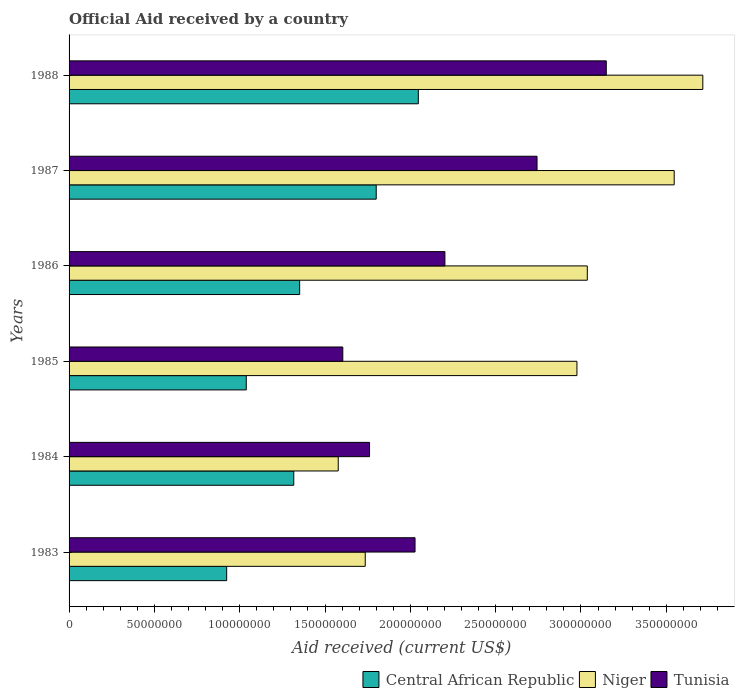How many different coloured bars are there?
Offer a very short reply. 3. Are the number of bars per tick equal to the number of legend labels?
Keep it short and to the point. Yes. Are the number of bars on each tick of the Y-axis equal?
Make the answer very short. Yes. How many bars are there on the 2nd tick from the top?
Provide a succinct answer. 3. How many bars are there on the 6th tick from the bottom?
Offer a terse response. 3. What is the label of the 1st group of bars from the top?
Ensure brevity in your answer.  1988. In how many cases, is the number of bars for a given year not equal to the number of legend labels?
Offer a very short reply. 0. What is the net official aid received in Tunisia in 1987?
Give a very brief answer. 2.74e+08. Across all years, what is the maximum net official aid received in Niger?
Ensure brevity in your answer.  3.71e+08. Across all years, what is the minimum net official aid received in Niger?
Provide a short and direct response. 1.58e+08. What is the total net official aid received in Central African Republic in the graph?
Provide a short and direct response. 8.48e+08. What is the difference between the net official aid received in Niger in 1987 and that in 1988?
Your answer should be compact. -1.68e+07. What is the difference between the net official aid received in Tunisia in 1986 and the net official aid received in Niger in 1984?
Keep it short and to the point. 6.25e+07. What is the average net official aid received in Tunisia per year?
Give a very brief answer. 2.25e+08. In the year 1985, what is the difference between the net official aid received in Tunisia and net official aid received in Central African Republic?
Offer a very short reply. 5.66e+07. In how many years, is the net official aid received in Tunisia greater than 310000000 US$?
Your answer should be compact. 1. What is the ratio of the net official aid received in Tunisia in 1983 to that in 1986?
Make the answer very short. 0.92. What is the difference between the highest and the second highest net official aid received in Niger?
Ensure brevity in your answer.  1.68e+07. What is the difference between the highest and the lowest net official aid received in Niger?
Your answer should be very brief. 2.14e+08. Is the sum of the net official aid received in Niger in 1984 and 1988 greater than the maximum net official aid received in Central African Republic across all years?
Offer a terse response. Yes. What does the 2nd bar from the top in 1986 represents?
Ensure brevity in your answer.  Niger. What does the 2nd bar from the bottom in 1985 represents?
Provide a succinct answer. Niger. Is it the case that in every year, the sum of the net official aid received in Niger and net official aid received in Tunisia is greater than the net official aid received in Central African Republic?
Provide a short and direct response. Yes. Are all the bars in the graph horizontal?
Your answer should be compact. Yes. What is the difference between two consecutive major ticks on the X-axis?
Offer a very short reply. 5.00e+07. Does the graph contain any zero values?
Provide a short and direct response. No. Does the graph contain grids?
Offer a very short reply. No. Where does the legend appear in the graph?
Provide a succinct answer. Bottom right. How many legend labels are there?
Keep it short and to the point. 3. What is the title of the graph?
Your answer should be very brief. Official Aid received by a country. Does "Rwanda" appear as one of the legend labels in the graph?
Your response must be concise. No. What is the label or title of the X-axis?
Keep it short and to the point. Aid received (current US$). What is the label or title of the Y-axis?
Make the answer very short. Years. What is the Aid received (current US$) of Central African Republic in 1983?
Provide a succinct answer. 9.24e+07. What is the Aid received (current US$) in Niger in 1983?
Your answer should be very brief. 1.74e+08. What is the Aid received (current US$) in Tunisia in 1983?
Offer a terse response. 2.03e+08. What is the Aid received (current US$) of Central African Republic in 1984?
Offer a terse response. 1.32e+08. What is the Aid received (current US$) of Niger in 1984?
Provide a succinct answer. 1.58e+08. What is the Aid received (current US$) in Tunisia in 1984?
Make the answer very short. 1.76e+08. What is the Aid received (current US$) in Central African Republic in 1985?
Your response must be concise. 1.04e+08. What is the Aid received (current US$) of Niger in 1985?
Keep it short and to the point. 2.98e+08. What is the Aid received (current US$) in Tunisia in 1985?
Offer a very short reply. 1.60e+08. What is the Aid received (current US$) in Central African Republic in 1986?
Your response must be concise. 1.35e+08. What is the Aid received (current US$) of Niger in 1986?
Make the answer very short. 3.04e+08. What is the Aid received (current US$) of Tunisia in 1986?
Your answer should be very brief. 2.20e+08. What is the Aid received (current US$) of Central African Republic in 1987?
Provide a short and direct response. 1.80e+08. What is the Aid received (current US$) of Niger in 1987?
Offer a very short reply. 3.55e+08. What is the Aid received (current US$) of Tunisia in 1987?
Offer a terse response. 2.74e+08. What is the Aid received (current US$) in Central African Republic in 1988?
Keep it short and to the point. 2.05e+08. What is the Aid received (current US$) in Niger in 1988?
Provide a short and direct response. 3.71e+08. What is the Aid received (current US$) of Tunisia in 1988?
Offer a terse response. 3.15e+08. Across all years, what is the maximum Aid received (current US$) of Central African Republic?
Offer a very short reply. 2.05e+08. Across all years, what is the maximum Aid received (current US$) in Niger?
Your answer should be compact. 3.71e+08. Across all years, what is the maximum Aid received (current US$) of Tunisia?
Offer a very short reply. 3.15e+08. Across all years, what is the minimum Aid received (current US$) in Central African Republic?
Ensure brevity in your answer.  9.24e+07. Across all years, what is the minimum Aid received (current US$) of Niger?
Your answer should be compact. 1.58e+08. Across all years, what is the minimum Aid received (current US$) of Tunisia?
Provide a succinct answer. 1.60e+08. What is the total Aid received (current US$) in Central African Republic in the graph?
Your answer should be very brief. 8.48e+08. What is the total Aid received (current US$) in Niger in the graph?
Your answer should be compact. 1.66e+09. What is the total Aid received (current US$) of Tunisia in the graph?
Provide a succinct answer. 1.35e+09. What is the difference between the Aid received (current US$) in Central African Republic in 1983 and that in 1984?
Your answer should be compact. -3.93e+07. What is the difference between the Aid received (current US$) of Niger in 1983 and that in 1984?
Keep it short and to the point. 1.58e+07. What is the difference between the Aid received (current US$) of Tunisia in 1983 and that in 1984?
Your answer should be very brief. 2.67e+07. What is the difference between the Aid received (current US$) of Central African Republic in 1983 and that in 1985?
Provide a succinct answer. -1.15e+07. What is the difference between the Aid received (current US$) of Niger in 1983 and that in 1985?
Your answer should be very brief. -1.24e+08. What is the difference between the Aid received (current US$) of Tunisia in 1983 and that in 1985?
Offer a terse response. 4.23e+07. What is the difference between the Aid received (current US$) of Central African Republic in 1983 and that in 1986?
Provide a short and direct response. -4.28e+07. What is the difference between the Aid received (current US$) of Niger in 1983 and that in 1986?
Offer a terse response. -1.30e+08. What is the difference between the Aid received (current US$) in Tunisia in 1983 and that in 1986?
Offer a terse response. -1.75e+07. What is the difference between the Aid received (current US$) in Central African Republic in 1983 and that in 1987?
Offer a very short reply. -8.76e+07. What is the difference between the Aid received (current US$) in Niger in 1983 and that in 1987?
Your response must be concise. -1.81e+08. What is the difference between the Aid received (current US$) in Tunisia in 1983 and that in 1987?
Make the answer very short. -7.15e+07. What is the difference between the Aid received (current US$) in Central African Republic in 1983 and that in 1988?
Ensure brevity in your answer.  -1.12e+08. What is the difference between the Aid received (current US$) in Niger in 1983 and that in 1988?
Offer a very short reply. -1.98e+08. What is the difference between the Aid received (current US$) in Tunisia in 1983 and that in 1988?
Your response must be concise. -1.12e+08. What is the difference between the Aid received (current US$) of Central African Republic in 1984 and that in 1985?
Ensure brevity in your answer.  2.78e+07. What is the difference between the Aid received (current US$) of Niger in 1984 and that in 1985?
Provide a succinct answer. -1.40e+08. What is the difference between the Aid received (current US$) of Tunisia in 1984 and that in 1985?
Your response must be concise. 1.57e+07. What is the difference between the Aid received (current US$) of Central African Republic in 1984 and that in 1986?
Offer a very short reply. -3.45e+06. What is the difference between the Aid received (current US$) in Niger in 1984 and that in 1986?
Your response must be concise. -1.46e+08. What is the difference between the Aid received (current US$) of Tunisia in 1984 and that in 1986?
Provide a short and direct response. -4.42e+07. What is the difference between the Aid received (current US$) in Central African Republic in 1984 and that in 1987?
Ensure brevity in your answer.  -4.83e+07. What is the difference between the Aid received (current US$) of Niger in 1984 and that in 1987?
Make the answer very short. -1.97e+08. What is the difference between the Aid received (current US$) in Tunisia in 1984 and that in 1987?
Your answer should be compact. -9.82e+07. What is the difference between the Aid received (current US$) in Central African Republic in 1984 and that in 1988?
Keep it short and to the point. -7.30e+07. What is the difference between the Aid received (current US$) in Niger in 1984 and that in 1988?
Give a very brief answer. -2.14e+08. What is the difference between the Aid received (current US$) of Tunisia in 1984 and that in 1988?
Ensure brevity in your answer.  -1.39e+08. What is the difference between the Aid received (current US$) in Central African Republic in 1985 and that in 1986?
Give a very brief answer. -3.13e+07. What is the difference between the Aid received (current US$) of Niger in 1985 and that in 1986?
Your answer should be very brief. -6.07e+06. What is the difference between the Aid received (current US$) of Tunisia in 1985 and that in 1986?
Your answer should be compact. -5.98e+07. What is the difference between the Aid received (current US$) of Central African Republic in 1985 and that in 1987?
Provide a succinct answer. -7.62e+07. What is the difference between the Aid received (current US$) in Niger in 1985 and that in 1987?
Your response must be concise. -5.70e+07. What is the difference between the Aid received (current US$) of Tunisia in 1985 and that in 1987?
Your answer should be very brief. -1.14e+08. What is the difference between the Aid received (current US$) in Central African Republic in 1985 and that in 1988?
Keep it short and to the point. -1.01e+08. What is the difference between the Aid received (current US$) of Niger in 1985 and that in 1988?
Your response must be concise. -7.38e+07. What is the difference between the Aid received (current US$) of Tunisia in 1985 and that in 1988?
Your response must be concise. -1.54e+08. What is the difference between the Aid received (current US$) of Central African Republic in 1986 and that in 1987?
Ensure brevity in your answer.  -4.49e+07. What is the difference between the Aid received (current US$) in Niger in 1986 and that in 1987?
Offer a terse response. -5.09e+07. What is the difference between the Aid received (current US$) in Tunisia in 1986 and that in 1987?
Make the answer very short. -5.40e+07. What is the difference between the Aid received (current US$) of Central African Republic in 1986 and that in 1988?
Offer a very short reply. -6.96e+07. What is the difference between the Aid received (current US$) of Niger in 1986 and that in 1988?
Offer a very short reply. -6.77e+07. What is the difference between the Aid received (current US$) of Tunisia in 1986 and that in 1988?
Make the answer very short. -9.46e+07. What is the difference between the Aid received (current US$) in Central African Republic in 1987 and that in 1988?
Offer a very short reply. -2.47e+07. What is the difference between the Aid received (current US$) of Niger in 1987 and that in 1988?
Keep it short and to the point. -1.68e+07. What is the difference between the Aid received (current US$) of Tunisia in 1987 and that in 1988?
Provide a succinct answer. -4.06e+07. What is the difference between the Aid received (current US$) in Central African Republic in 1983 and the Aid received (current US$) in Niger in 1984?
Give a very brief answer. -6.54e+07. What is the difference between the Aid received (current US$) of Central African Republic in 1983 and the Aid received (current US$) of Tunisia in 1984?
Make the answer very short. -8.37e+07. What is the difference between the Aid received (current US$) of Niger in 1983 and the Aid received (current US$) of Tunisia in 1984?
Ensure brevity in your answer.  -2.53e+06. What is the difference between the Aid received (current US$) in Central African Republic in 1983 and the Aid received (current US$) in Niger in 1985?
Provide a short and direct response. -2.05e+08. What is the difference between the Aid received (current US$) of Central African Republic in 1983 and the Aid received (current US$) of Tunisia in 1985?
Ensure brevity in your answer.  -6.81e+07. What is the difference between the Aid received (current US$) of Niger in 1983 and the Aid received (current US$) of Tunisia in 1985?
Your answer should be compact. 1.32e+07. What is the difference between the Aid received (current US$) of Central African Republic in 1983 and the Aid received (current US$) of Niger in 1986?
Provide a succinct answer. -2.11e+08. What is the difference between the Aid received (current US$) of Central African Republic in 1983 and the Aid received (current US$) of Tunisia in 1986?
Provide a short and direct response. -1.28e+08. What is the difference between the Aid received (current US$) of Niger in 1983 and the Aid received (current US$) of Tunisia in 1986?
Offer a very short reply. -4.67e+07. What is the difference between the Aid received (current US$) in Central African Republic in 1983 and the Aid received (current US$) in Niger in 1987?
Your answer should be compact. -2.62e+08. What is the difference between the Aid received (current US$) in Central African Republic in 1983 and the Aid received (current US$) in Tunisia in 1987?
Your answer should be compact. -1.82e+08. What is the difference between the Aid received (current US$) of Niger in 1983 and the Aid received (current US$) of Tunisia in 1987?
Provide a succinct answer. -1.01e+08. What is the difference between the Aid received (current US$) in Central African Republic in 1983 and the Aid received (current US$) in Niger in 1988?
Ensure brevity in your answer.  -2.79e+08. What is the difference between the Aid received (current US$) in Central African Republic in 1983 and the Aid received (current US$) in Tunisia in 1988?
Provide a succinct answer. -2.22e+08. What is the difference between the Aid received (current US$) in Niger in 1983 and the Aid received (current US$) in Tunisia in 1988?
Your answer should be very brief. -1.41e+08. What is the difference between the Aid received (current US$) of Central African Republic in 1984 and the Aid received (current US$) of Niger in 1985?
Your answer should be very brief. -1.66e+08. What is the difference between the Aid received (current US$) in Central African Republic in 1984 and the Aid received (current US$) in Tunisia in 1985?
Your answer should be compact. -2.87e+07. What is the difference between the Aid received (current US$) of Niger in 1984 and the Aid received (current US$) of Tunisia in 1985?
Make the answer very short. -2.67e+06. What is the difference between the Aid received (current US$) in Central African Republic in 1984 and the Aid received (current US$) in Niger in 1986?
Offer a very short reply. -1.72e+08. What is the difference between the Aid received (current US$) in Central African Republic in 1984 and the Aid received (current US$) in Tunisia in 1986?
Provide a short and direct response. -8.86e+07. What is the difference between the Aid received (current US$) in Niger in 1984 and the Aid received (current US$) in Tunisia in 1986?
Your response must be concise. -6.25e+07. What is the difference between the Aid received (current US$) in Central African Republic in 1984 and the Aid received (current US$) in Niger in 1987?
Your answer should be compact. -2.23e+08. What is the difference between the Aid received (current US$) in Central African Republic in 1984 and the Aid received (current US$) in Tunisia in 1987?
Make the answer very short. -1.43e+08. What is the difference between the Aid received (current US$) of Niger in 1984 and the Aid received (current US$) of Tunisia in 1987?
Your response must be concise. -1.17e+08. What is the difference between the Aid received (current US$) of Central African Republic in 1984 and the Aid received (current US$) of Niger in 1988?
Your response must be concise. -2.40e+08. What is the difference between the Aid received (current US$) of Central African Republic in 1984 and the Aid received (current US$) of Tunisia in 1988?
Provide a short and direct response. -1.83e+08. What is the difference between the Aid received (current US$) of Niger in 1984 and the Aid received (current US$) of Tunisia in 1988?
Give a very brief answer. -1.57e+08. What is the difference between the Aid received (current US$) in Central African Republic in 1985 and the Aid received (current US$) in Niger in 1986?
Offer a very short reply. -2.00e+08. What is the difference between the Aid received (current US$) in Central African Republic in 1985 and the Aid received (current US$) in Tunisia in 1986?
Provide a succinct answer. -1.16e+08. What is the difference between the Aid received (current US$) in Niger in 1985 and the Aid received (current US$) in Tunisia in 1986?
Provide a succinct answer. 7.74e+07. What is the difference between the Aid received (current US$) of Central African Republic in 1985 and the Aid received (current US$) of Niger in 1987?
Provide a short and direct response. -2.51e+08. What is the difference between the Aid received (current US$) of Central African Republic in 1985 and the Aid received (current US$) of Tunisia in 1987?
Ensure brevity in your answer.  -1.70e+08. What is the difference between the Aid received (current US$) of Niger in 1985 and the Aid received (current US$) of Tunisia in 1987?
Provide a short and direct response. 2.34e+07. What is the difference between the Aid received (current US$) of Central African Republic in 1985 and the Aid received (current US$) of Niger in 1988?
Make the answer very short. -2.68e+08. What is the difference between the Aid received (current US$) of Central African Republic in 1985 and the Aid received (current US$) of Tunisia in 1988?
Give a very brief answer. -2.11e+08. What is the difference between the Aid received (current US$) of Niger in 1985 and the Aid received (current US$) of Tunisia in 1988?
Ensure brevity in your answer.  -1.72e+07. What is the difference between the Aid received (current US$) of Central African Republic in 1986 and the Aid received (current US$) of Niger in 1987?
Your response must be concise. -2.20e+08. What is the difference between the Aid received (current US$) in Central African Republic in 1986 and the Aid received (current US$) in Tunisia in 1987?
Provide a succinct answer. -1.39e+08. What is the difference between the Aid received (current US$) in Niger in 1986 and the Aid received (current US$) in Tunisia in 1987?
Make the answer very short. 2.94e+07. What is the difference between the Aid received (current US$) in Central African Republic in 1986 and the Aid received (current US$) in Niger in 1988?
Your answer should be compact. -2.36e+08. What is the difference between the Aid received (current US$) in Central African Republic in 1986 and the Aid received (current US$) in Tunisia in 1988?
Offer a very short reply. -1.80e+08. What is the difference between the Aid received (current US$) in Niger in 1986 and the Aid received (current US$) in Tunisia in 1988?
Give a very brief answer. -1.11e+07. What is the difference between the Aid received (current US$) in Central African Republic in 1987 and the Aid received (current US$) in Niger in 1988?
Provide a short and direct response. -1.91e+08. What is the difference between the Aid received (current US$) of Central African Republic in 1987 and the Aid received (current US$) of Tunisia in 1988?
Provide a short and direct response. -1.35e+08. What is the difference between the Aid received (current US$) in Niger in 1987 and the Aid received (current US$) in Tunisia in 1988?
Keep it short and to the point. 3.98e+07. What is the average Aid received (current US$) in Central African Republic per year?
Your answer should be very brief. 1.41e+08. What is the average Aid received (current US$) in Niger per year?
Make the answer very short. 2.76e+08. What is the average Aid received (current US$) in Tunisia per year?
Ensure brevity in your answer.  2.25e+08. In the year 1983, what is the difference between the Aid received (current US$) of Central African Republic and Aid received (current US$) of Niger?
Give a very brief answer. -8.12e+07. In the year 1983, what is the difference between the Aid received (current US$) in Central African Republic and Aid received (current US$) in Tunisia?
Give a very brief answer. -1.10e+08. In the year 1983, what is the difference between the Aid received (current US$) of Niger and Aid received (current US$) of Tunisia?
Offer a terse response. -2.92e+07. In the year 1984, what is the difference between the Aid received (current US$) in Central African Republic and Aid received (current US$) in Niger?
Provide a succinct answer. -2.61e+07. In the year 1984, what is the difference between the Aid received (current US$) of Central African Republic and Aid received (current US$) of Tunisia?
Provide a short and direct response. -4.44e+07. In the year 1984, what is the difference between the Aid received (current US$) in Niger and Aid received (current US$) in Tunisia?
Your response must be concise. -1.84e+07. In the year 1985, what is the difference between the Aid received (current US$) in Central African Republic and Aid received (current US$) in Niger?
Provide a short and direct response. -1.94e+08. In the year 1985, what is the difference between the Aid received (current US$) in Central African Republic and Aid received (current US$) in Tunisia?
Offer a very short reply. -5.66e+07. In the year 1985, what is the difference between the Aid received (current US$) in Niger and Aid received (current US$) in Tunisia?
Your response must be concise. 1.37e+08. In the year 1986, what is the difference between the Aid received (current US$) in Central African Republic and Aid received (current US$) in Niger?
Your answer should be compact. -1.69e+08. In the year 1986, what is the difference between the Aid received (current US$) in Central African Republic and Aid received (current US$) in Tunisia?
Make the answer very short. -8.51e+07. In the year 1986, what is the difference between the Aid received (current US$) in Niger and Aid received (current US$) in Tunisia?
Your response must be concise. 8.34e+07. In the year 1987, what is the difference between the Aid received (current US$) of Central African Republic and Aid received (current US$) of Niger?
Offer a terse response. -1.75e+08. In the year 1987, what is the difference between the Aid received (current US$) of Central African Republic and Aid received (current US$) of Tunisia?
Offer a very short reply. -9.42e+07. In the year 1987, what is the difference between the Aid received (current US$) in Niger and Aid received (current US$) in Tunisia?
Offer a terse response. 8.04e+07. In the year 1988, what is the difference between the Aid received (current US$) of Central African Republic and Aid received (current US$) of Niger?
Offer a very short reply. -1.67e+08. In the year 1988, what is the difference between the Aid received (current US$) of Central African Republic and Aid received (current US$) of Tunisia?
Offer a very short reply. -1.10e+08. In the year 1988, what is the difference between the Aid received (current US$) in Niger and Aid received (current US$) in Tunisia?
Offer a very short reply. 5.66e+07. What is the ratio of the Aid received (current US$) in Central African Republic in 1983 to that in 1984?
Give a very brief answer. 0.7. What is the ratio of the Aid received (current US$) of Niger in 1983 to that in 1984?
Offer a terse response. 1.1. What is the ratio of the Aid received (current US$) in Tunisia in 1983 to that in 1984?
Keep it short and to the point. 1.15. What is the ratio of the Aid received (current US$) in Central African Republic in 1983 to that in 1985?
Offer a terse response. 0.89. What is the ratio of the Aid received (current US$) in Niger in 1983 to that in 1985?
Give a very brief answer. 0.58. What is the ratio of the Aid received (current US$) in Tunisia in 1983 to that in 1985?
Make the answer very short. 1.26. What is the ratio of the Aid received (current US$) of Central African Republic in 1983 to that in 1986?
Ensure brevity in your answer.  0.68. What is the ratio of the Aid received (current US$) in Niger in 1983 to that in 1986?
Ensure brevity in your answer.  0.57. What is the ratio of the Aid received (current US$) in Tunisia in 1983 to that in 1986?
Your response must be concise. 0.92. What is the ratio of the Aid received (current US$) in Central African Republic in 1983 to that in 1987?
Provide a succinct answer. 0.51. What is the ratio of the Aid received (current US$) of Niger in 1983 to that in 1987?
Make the answer very short. 0.49. What is the ratio of the Aid received (current US$) of Tunisia in 1983 to that in 1987?
Your response must be concise. 0.74. What is the ratio of the Aid received (current US$) of Central African Republic in 1983 to that in 1988?
Ensure brevity in your answer.  0.45. What is the ratio of the Aid received (current US$) of Niger in 1983 to that in 1988?
Offer a very short reply. 0.47. What is the ratio of the Aid received (current US$) of Tunisia in 1983 to that in 1988?
Provide a succinct answer. 0.64. What is the ratio of the Aid received (current US$) in Central African Republic in 1984 to that in 1985?
Your answer should be very brief. 1.27. What is the ratio of the Aid received (current US$) in Niger in 1984 to that in 1985?
Make the answer very short. 0.53. What is the ratio of the Aid received (current US$) in Tunisia in 1984 to that in 1985?
Offer a terse response. 1.1. What is the ratio of the Aid received (current US$) in Central African Republic in 1984 to that in 1986?
Your answer should be compact. 0.97. What is the ratio of the Aid received (current US$) in Niger in 1984 to that in 1986?
Ensure brevity in your answer.  0.52. What is the ratio of the Aid received (current US$) in Tunisia in 1984 to that in 1986?
Provide a succinct answer. 0.8. What is the ratio of the Aid received (current US$) of Central African Republic in 1984 to that in 1987?
Make the answer very short. 0.73. What is the ratio of the Aid received (current US$) in Niger in 1984 to that in 1987?
Provide a short and direct response. 0.44. What is the ratio of the Aid received (current US$) of Tunisia in 1984 to that in 1987?
Offer a very short reply. 0.64. What is the ratio of the Aid received (current US$) in Central African Republic in 1984 to that in 1988?
Your answer should be very brief. 0.64. What is the ratio of the Aid received (current US$) in Niger in 1984 to that in 1988?
Keep it short and to the point. 0.42. What is the ratio of the Aid received (current US$) in Tunisia in 1984 to that in 1988?
Give a very brief answer. 0.56. What is the ratio of the Aid received (current US$) in Central African Republic in 1985 to that in 1986?
Your answer should be very brief. 0.77. What is the ratio of the Aid received (current US$) in Niger in 1985 to that in 1986?
Ensure brevity in your answer.  0.98. What is the ratio of the Aid received (current US$) of Tunisia in 1985 to that in 1986?
Provide a short and direct response. 0.73. What is the ratio of the Aid received (current US$) of Central African Republic in 1985 to that in 1987?
Your answer should be very brief. 0.58. What is the ratio of the Aid received (current US$) in Niger in 1985 to that in 1987?
Your answer should be compact. 0.84. What is the ratio of the Aid received (current US$) in Tunisia in 1985 to that in 1987?
Provide a short and direct response. 0.58. What is the ratio of the Aid received (current US$) in Central African Republic in 1985 to that in 1988?
Keep it short and to the point. 0.51. What is the ratio of the Aid received (current US$) of Niger in 1985 to that in 1988?
Your answer should be very brief. 0.8. What is the ratio of the Aid received (current US$) in Tunisia in 1985 to that in 1988?
Keep it short and to the point. 0.51. What is the ratio of the Aid received (current US$) in Central African Republic in 1986 to that in 1987?
Provide a short and direct response. 0.75. What is the ratio of the Aid received (current US$) in Niger in 1986 to that in 1987?
Your response must be concise. 0.86. What is the ratio of the Aid received (current US$) of Tunisia in 1986 to that in 1987?
Offer a very short reply. 0.8. What is the ratio of the Aid received (current US$) of Central African Republic in 1986 to that in 1988?
Ensure brevity in your answer.  0.66. What is the ratio of the Aid received (current US$) of Niger in 1986 to that in 1988?
Your response must be concise. 0.82. What is the ratio of the Aid received (current US$) in Tunisia in 1986 to that in 1988?
Your answer should be very brief. 0.7. What is the ratio of the Aid received (current US$) in Central African Republic in 1987 to that in 1988?
Your answer should be very brief. 0.88. What is the ratio of the Aid received (current US$) in Niger in 1987 to that in 1988?
Your answer should be compact. 0.95. What is the ratio of the Aid received (current US$) of Tunisia in 1987 to that in 1988?
Give a very brief answer. 0.87. What is the difference between the highest and the second highest Aid received (current US$) of Central African Republic?
Offer a very short reply. 2.47e+07. What is the difference between the highest and the second highest Aid received (current US$) of Niger?
Give a very brief answer. 1.68e+07. What is the difference between the highest and the second highest Aid received (current US$) in Tunisia?
Provide a succinct answer. 4.06e+07. What is the difference between the highest and the lowest Aid received (current US$) of Central African Republic?
Offer a very short reply. 1.12e+08. What is the difference between the highest and the lowest Aid received (current US$) in Niger?
Give a very brief answer. 2.14e+08. What is the difference between the highest and the lowest Aid received (current US$) in Tunisia?
Keep it short and to the point. 1.54e+08. 